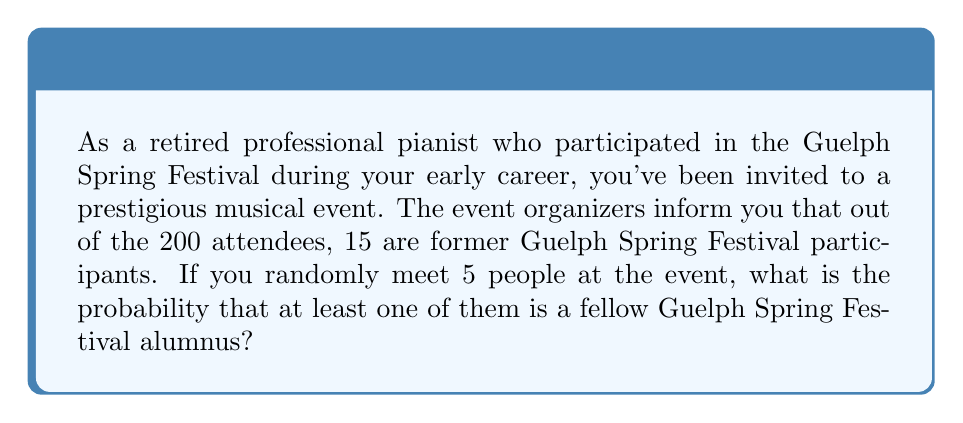Could you help me with this problem? Let's approach this step-by-step:

1) First, let's calculate the probability of meeting someone who is not a Guelph Spring Festival alumnus:

   $P(\text{not alumnus}) = \frac{200 - 15}{200} = \frac{185}{200} = 0.925$

2) The probability of all 5 people you meet not being alumni is:

   $P(\text{all 5 not alumni}) = (0.925)^5 = 0.6859140625$

3) Therefore, the probability of at least one person being an alumnus is the complement of this probability:

   $P(\text{at least one alumnus}) = 1 - P(\text{all 5 not alumni})$

   $= 1 - 0.6859140625 = 0.3140859375$

4) We can also calculate this using the binomial probability formula:

   $P(X \geq 1) = 1 - P(X = 0)$

   Where $X$ is the number of alumni met, and:

   $P(X = 0) = \binom{5}{0} (0.075)^0 (0.925)^5 = 0.6859140625$

   This confirms our earlier calculation.
Answer: The probability of meeting at least one fellow Guelph Spring Festival alumnus when randomly meeting 5 people at the event is approximately $0.3141$ or $31.41\%$. 